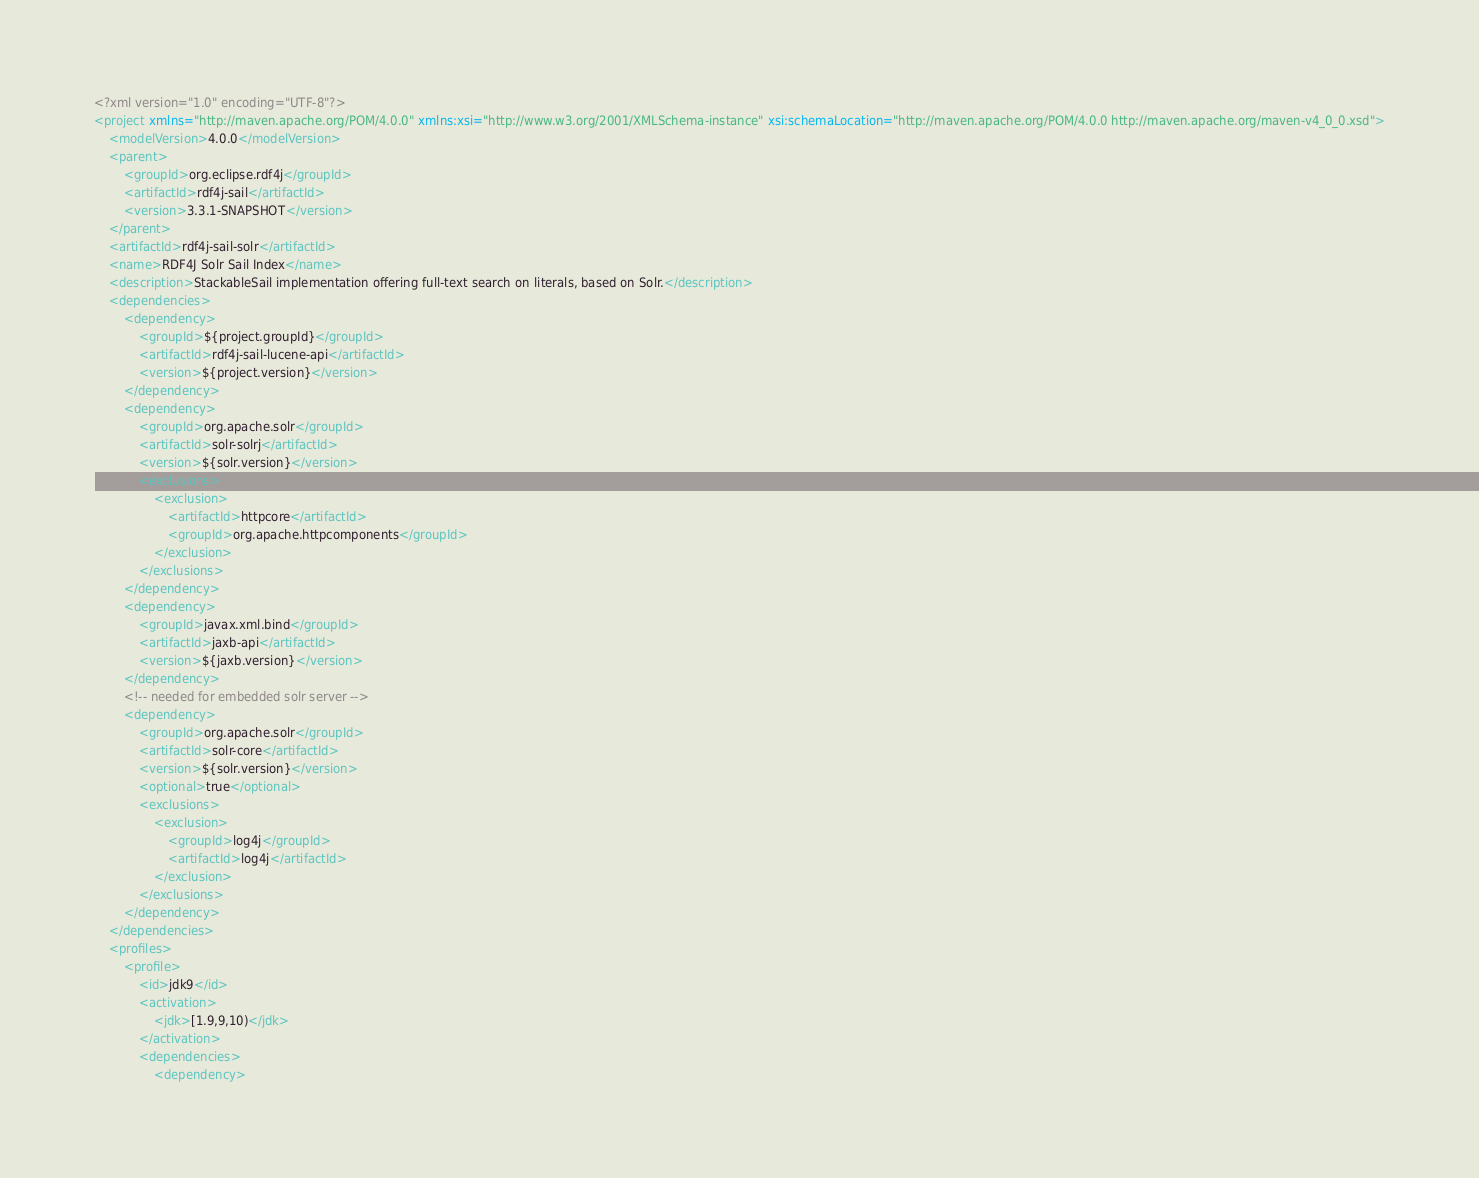<code> <loc_0><loc_0><loc_500><loc_500><_XML_><?xml version="1.0" encoding="UTF-8"?>
<project xmlns="http://maven.apache.org/POM/4.0.0" xmlns:xsi="http://www.w3.org/2001/XMLSchema-instance" xsi:schemaLocation="http://maven.apache.org/POM/4.0.0 http://maven.apache.org/maven-v4_0_0.xsd">
	<modelVersion>4.0.0</modelVersion>
	<parent>
		<groupId>org.eclipse.rdf4j</groupId>
		<artifactId>rdf4j-sail</artifactId>
		<version>3.3.1-SNAPSHOT</version>
	</parent>
	<artifactId>rdf4j-sail-solr</artifactId>
	<name>RDF4J Solr Sail Index</name>
	<description>StackableSail implementation offering full-text search on literals, based on Solr.</description>
	<dependencies>
		<dependency>
			<groupId>${project.groupId}</groupId>
			<artifactId>rdf4j-sail-lucene-api</artifactId>
			<version>${project.version}</version>
		</dependency>
		<dependency>
			<groupId>org.apache.solr</groupId>
			<artifactId>solr-solrj</artifactId>
			<version>${solr.version}</version>
			<exclusions>
				<exclusion>
					<artifactId>httpcore</artifactId>
					<groupId>org.apache.httpcomponents</groupId>
				</exclusion>
			</exclusions>
		</dependency>
		<dependency>
			<groupId>javax.xml.bind</groupId>
			<artifactId>jaxb-api</artifactId>
			<version>${jaxb.version}</version>
		</dependency>
		<!-- needed for embedded solr server -->
		<dependency>
			<groupId>org.apache.solr</groupId>
			<artifactId>solr-core</artifactId>
			<version>${solr.version}</version>
			<optional>true</optional>
			<exclusions>
				<exclusion>
					<groupId>log4j</groupId>
					<artifactId>log4j</artifactId>
				</exclusion>
			</exclusions>
		</dependency>
	</dependencies>
	<profiles>
		<profile>
			<id>jdk9</id>
			<activation>
				<jdk>[1.9,9,10)</jdk>
			</activation>
			<dependencies>
				<dependency></code> 